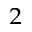Convert formula to latex. <formula><loc_0><loc_0><loc_500><loc_500>_ { 2 }</formula> 